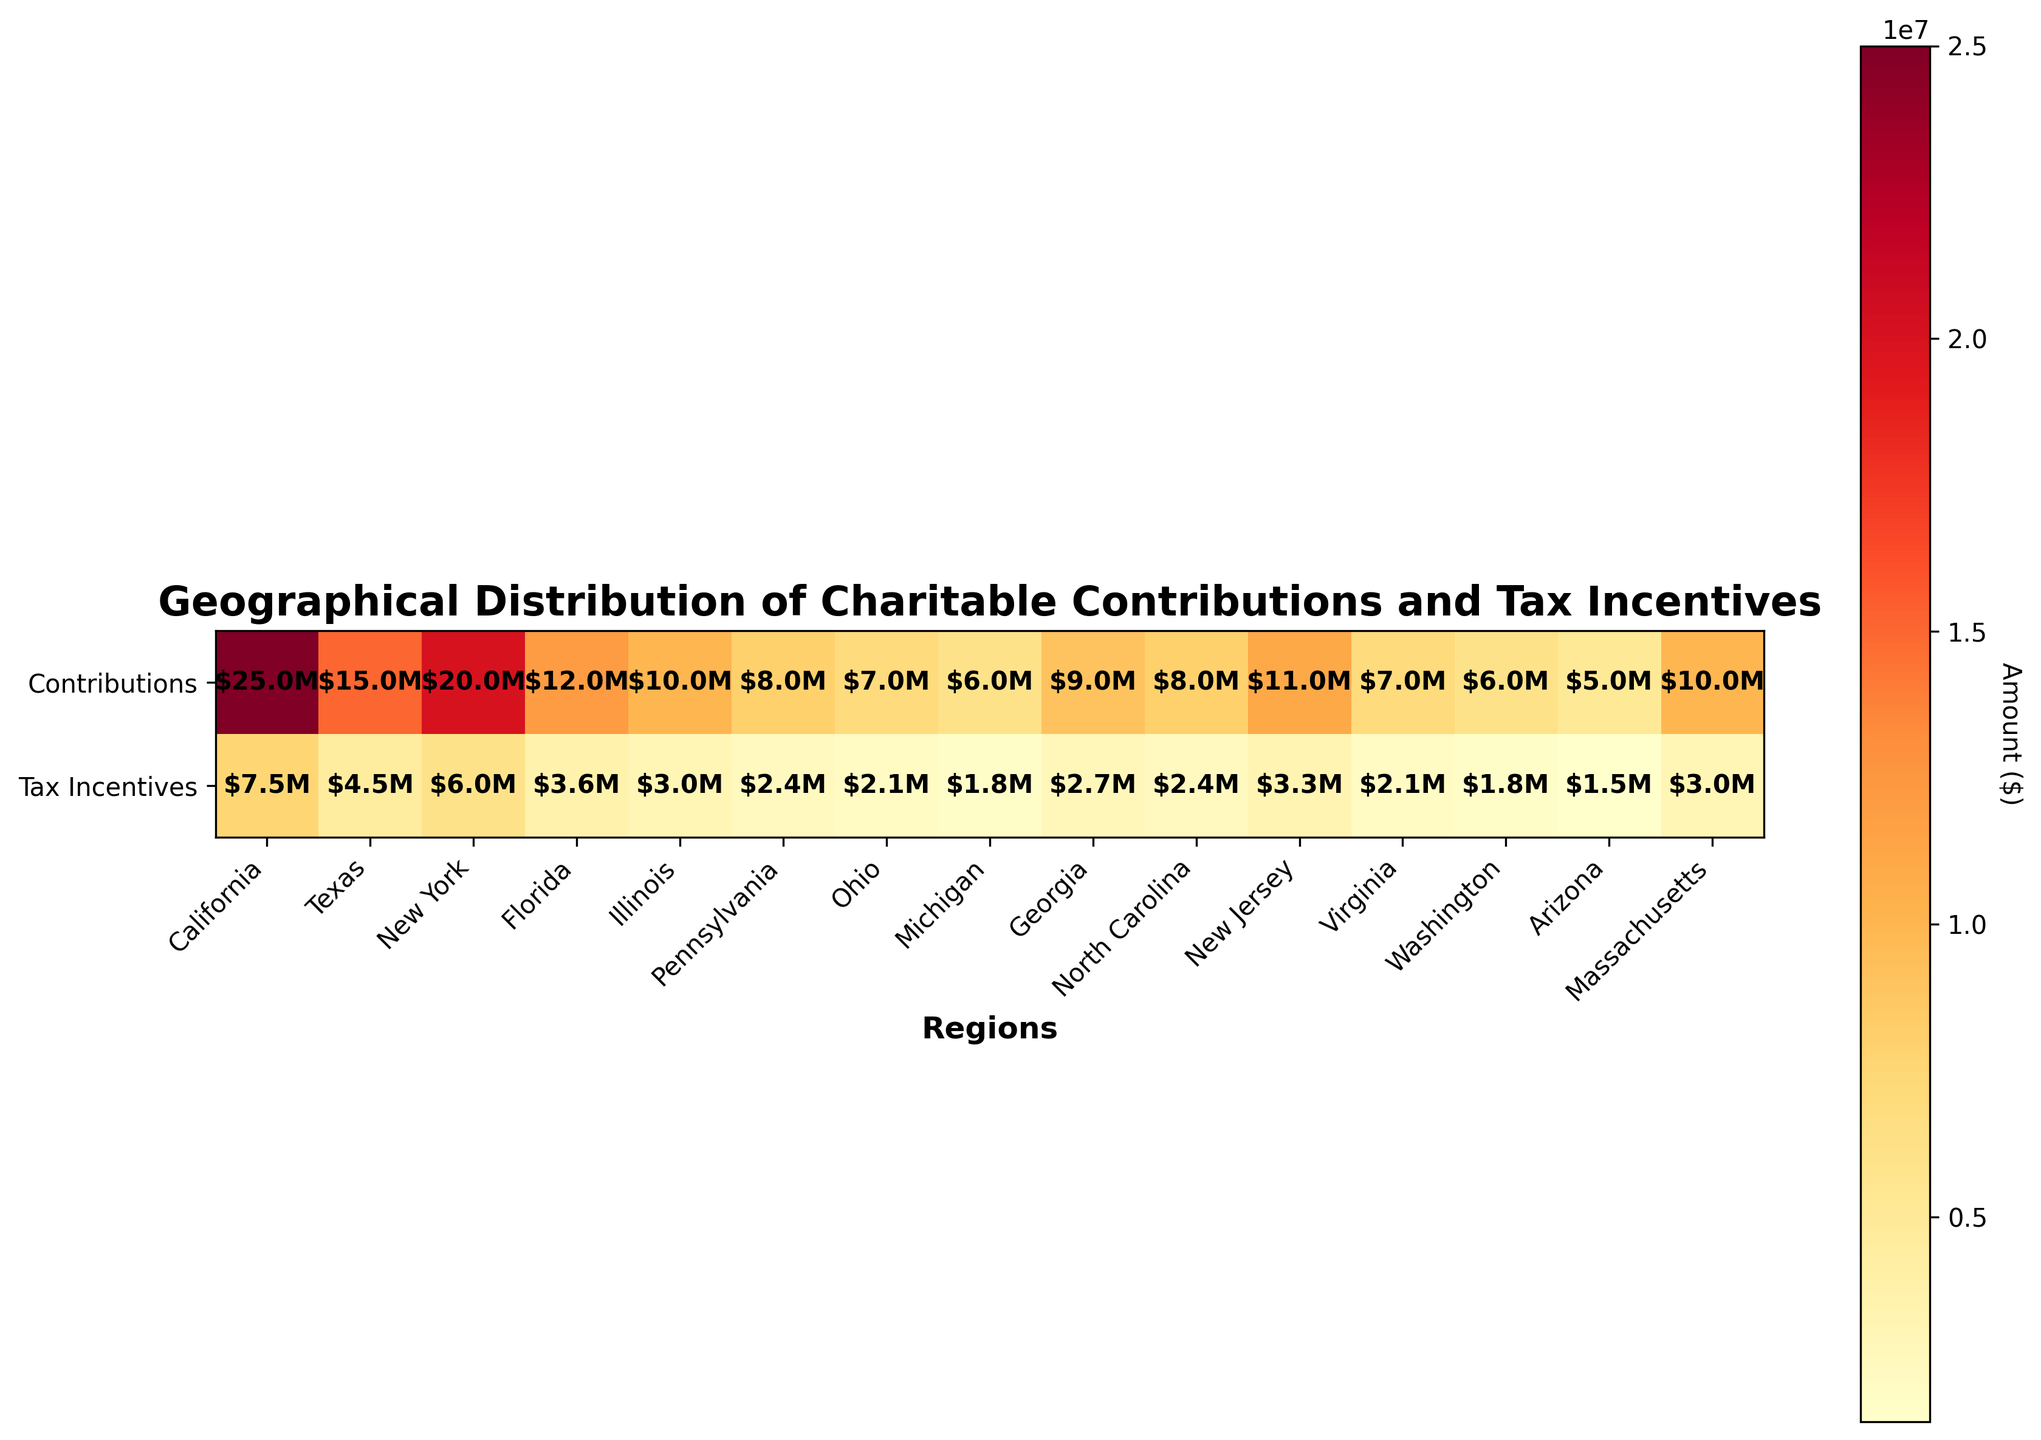What is the total charitable contribution displayed for California? The figure shows $25.0 million under the 'Contributions' row for California.
Answer: $25.0 million How much tax incentive was claimed in New York? The figure shows $6.0 million under the 'Tax Incentives' row for New York.
Answer: $6.0 million Which region has the lowest total charitable contribution? The heatmap indicates Arizona has the lowest total charitable contribution at $5.0 million.
Answer: Arizona What's the difference between the charitable contributions in Texas and California? The contributions displayed for Texas are $15.0 million, and for California, they are $25.0 million. The difference is $25.0 million - $15.0 million = $10.0 million.
Answer: $10.0 million Which region has a higher tax incentive claimed, Illinois or New Jersey? Illinois has $3.0 million claimed, while New Jersey has $3.3 million. New Jersey has a higher tax incentive.
Answer: New Jersey What is the sum of tax incentives claimed in Florida, Ohio, and Michigan? Florida has $3.6 million, Ohio has $2.1 million, and Michigan has $1.8 million. The total is $3.6M + $2.1M + $1.8M = $7.5 million.
Answer: $7.5 million Which region has a higher ratio of tax incentives to charitable contributions, Massachusetts or Virginia? Massachusetts data shows $10 million contributions and $3 million tax incentives, giving a ratio of 0.3. Virginia data shows $7 million contributions and $2.1 million tax incentives, giving a ratio of 0.3. Both regions have the same ratio of 0.3.
Answer: Equal How many regions have total charitable contributions of at least $10 million? The heatmap shows seven regions with contributions of at least $10 million: California, Texas, New York, Florida, Illinois, New Jersey, and Massachusetts.
Answer: Seven regions What region has the median value of total charitable contributions when sorted in descending order? When sorting the contributions in descending order, the middle region (median) is New York with $20.0 million.
Answer: New York Explain the pattern observed in the color intensity for contributions and tax incentives? The figure uses a heatmap with 'YlOrRd' colormap, where lighter colors represent lower values and darker colors represent higher values. California, having the highest values, appears darkest, while Arizona, with the lowest, appears lightest. Generally, higher contributions correlate with higher tax incentives across regions.
Answer: Higher contributions correlate with higher tax incentives across regions 